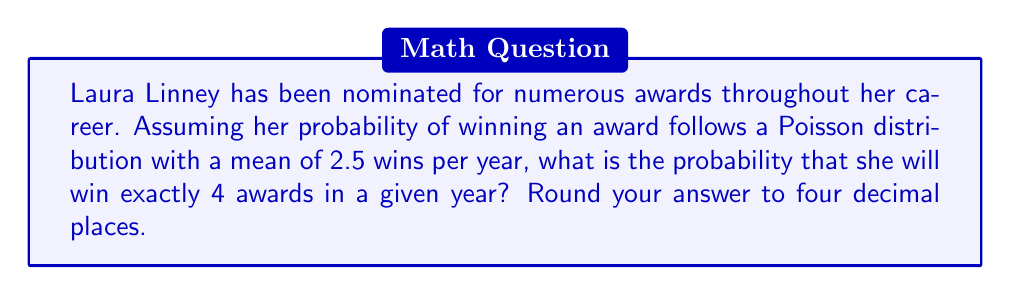What is the answer to this math problem? To solve this problem, we'll use the Poisson distribution formula:

$$P(X = k) = \frac{e^{-\lambda} \lambda^k}{k!}$$

Where:
$\lambda$ = mean number of events (in this case, awards won per year) = 2.5
$k$ = number of events we're calculating the probability for = 4
$e$ = Euler's number ≈ 2.71828

Let's substitute these values into the formula:

$$P(X = 4) = \frac{e^{-2.5} (2.5)^4}{4!}$$

Now, let's calculate step-by-step:

1) First, calculate $e^{-2.5}$:
   $e^{-2.5} \approx 0.0820$

2) Calculate $(2.5)^4$:
   $(2.5)^4 = 39.0625$

3) Calculate $4!$:
   $4! = 4 \times 3 \times 2 \times 1 = 24$

4) Now, put it all together:

   $$P(X = 4) = \frac{0.0820 \times 39.0625}{24}$$

5) Simplify:
   $$P(X = 4) = \frac{3.203125}{24} \approx 0.1334$$

6) Round to four decimal places:
   $P(X = 4) \approx 0.1334$
Answer: 0.1334 